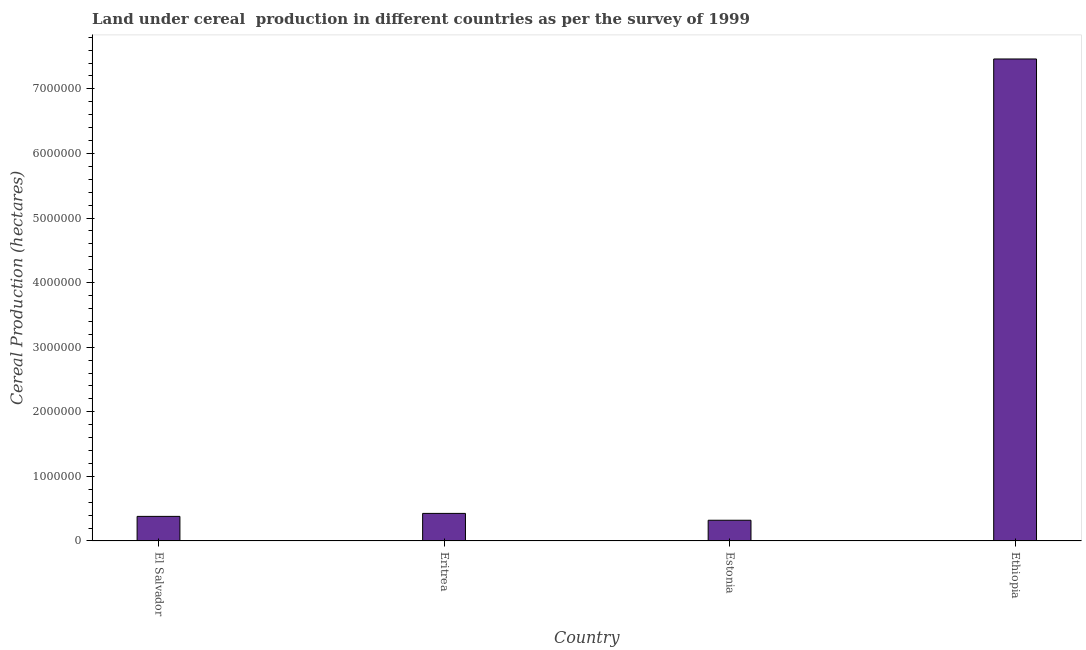What is the title of the graph?
Provide a short and direct response. Land under cereal  production in different countries as per the survey of 1999. What is the label or title of the X-axis?
Ensure brevity in your answer.  Country. What is the label or title of the Y-axis?
Offer a very short reply. Cereal Production (hectares). What is the land under cereal production in Estonia?
Ensure brevity in your answer.  3.21e+05. Across all countries, what is the maximum land under cereal production?
Make the answer very short. 7.46e+06. Across all countries, what is the minimum land under cereal production?
Offer a terse response. 3.21e+05. In which country was the land under cereal production maximum?
Your answer should be compact. Ethiopia. In which country was the land under cereal production minimum?
Offer a terse response. Estonia. What is the sum of the land under cereal production?
Offer a very short reply. 8.59e+06. What is the difference between the land under cereal production in El Salvador and Estonia?
Offer a very short reply. 5.97e+04. What is the average land under cereal production per country?
Keep it short and to the point. 2.15e+06. What is the median land under cereal production?
Your answer should be compact. 4.04e+05. In how many countries, is the land under cereal production greater than 5400000 hectares?
Make the answer very short. 1. What is the ratio of the land under cereal production in Estonia to that in Ethiopia?
Make the answer very short. 0.04. Is the land under cereal production in El Salvador less than that in Ethiopia?
Give a very brief answer. Yes. Is the difference between the land under cereal production in Estonia and Ethiopia greater than the difference between any two countries?
Make the answer very short. Yes. What is the difference between the highest and the second highest land under cereal production?
Your answer should be compact. 7.04e+06. Is the sum of the land under cereal production in El Salvador and Eritrea greater than the maximum land under cereal production across all countries?
Your response must be concise. No. What is the difference between the highest and the lowest land under cereal production?
Give a very brief answer. 7.14e+06. How many bars are there?
Your response must be concise. 4. Are all the bars in the graph horizontal?
Ensure brevity in your answer.  No. How many countries are there in the graph?
Your answer should be compact. 4. Are the values on the major ticks of Y-axis written in scientific E-notation?
Offer a very short reply. No. What is the Cereal Production (hectares) of El Salvador?
Ensure brevity in your answer.  3.81e+05. What is the Cereal Production (hectares) of Eritrea?
Give a very brief answer. 4.27e+05. What is the Cereal Production (hectares) of Estonia?
Provide a short and direct response. 3.21e+05. What is the Cereal Production (hectares) in Ethiopia?
Ensure brevity in your answer.  7.46e+06. What is the difference between the Cereal Production (hectares) in El Salvador and Eritrea?
Give a very brief answer. -4.64e+04. What is the difference between the Cereal Production (hectares) in El Salvador and Estonia?
Your answer should be very brief. 5.97e+04. What is the difference between the Cereal Production (hectares) in El Salvador and Ethiopia?
Your answer should be very brief. -7.08e+06. What is the difference between the Cereal Production (hectares) in Eritrea and Estonia?
Provide a succinct answer. 1.06e+05. What is the difference between the Cereal Production (hectares) in Eritrea and Ethiopia?
Make the answer very short. -7.04e+06. What is the difference between the Cereal Production (hectares) in Estonia and Ethiopia?
Make the answer very short. -7.14e+06. What is the ratio of the Cereal Production (hectares) in El Salvador to that in Eritrea?
Give a very brief answer. 0.89. What is the ratio of the Cereal Production (hectares) in El Salvador to that in Estonia?
Give a very brief answer. 1.19. What is the ratio of the Cereal Production (hectares) in El Salvador to that in Ethiopia?
Your answer should be very brief. 0.05. What is the ratio of the Cereal Production (hectares) in Eritrea to that in Estonia?
Your answer should be compact. 1.33. What is the ratio of the Cereal Production (hectares) in Eritrea to that in Ethiopia?
Make the answer very short. 0.06. What is the ratio of the Cereal Production (hectares) in Estonia to that in Ethiopia?
Your answer should be compact. 0.04. 